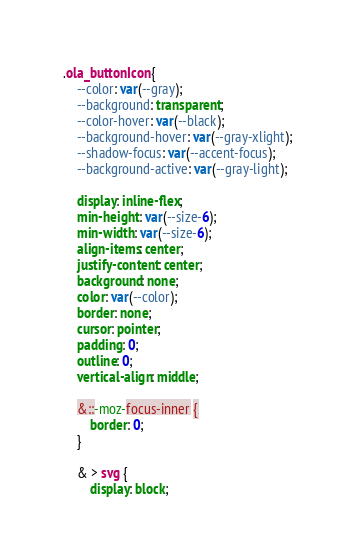<code> <loc_0><loc_0><loc_500><loc_500><_CSS_>.ola_buttonIcon {
    --color: var(--gray);
    --background: transparent;
    --color-hover: var(--black);
    --background-hover: var(--gray-xlight);
    --shadow-focus: var(--accent-focus);
    --background-active: var(--gray-light);

    display: inline-flex;
    min-height: var(--size-6);
    min-width: var(--size-6);
    align-items: center;
    justify-content: center;
    background: none;
    color: var(--color);
    border: none;
    cursor: pointer;
    padding: 0;
    outline: 0;
    vertical-align: middle;

    &::-moz-focus-inner {
        border: 0;
    }

    & > svg {
        display: block;</code> 